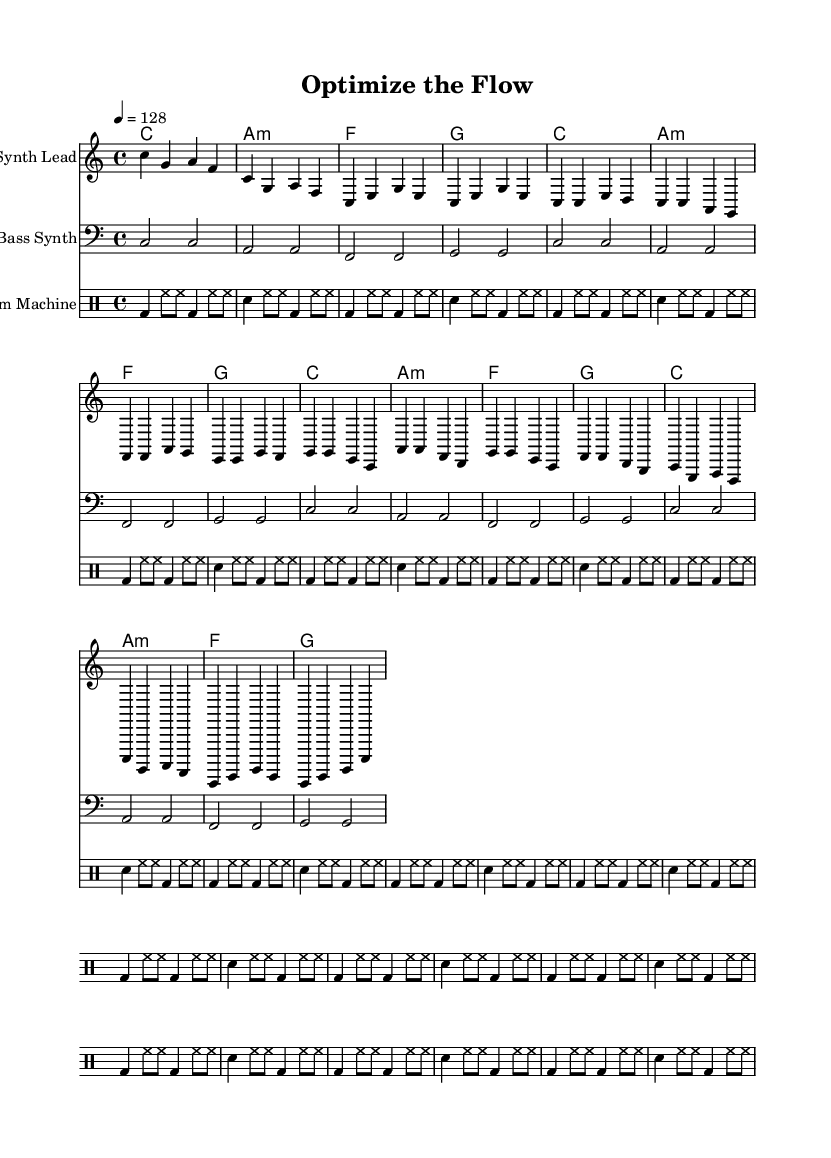What is the key signature of this music? The key signature is indicated at the beginning of the sheet music and shows C major, which has no sharps or flats.
Answer: C major What is the time signature of this music? The time signature is found at the beginning of the sheet music, showing 4/4, which means there are four beats in a measure and a quarter note gets one beat.
Answer: 4/4 What is the tempo marking for this piece? The tempo is specified as 4 = 128 at the start of the piece, indicating the speed of the music, which means to play at 128 beats per minute.
Answer: 128 What instruments are featured in the score? The score includes a "Synth Lead" staff for melody, a "Bass Synth" staff, and a "Drum Machine" staff for percussive elements, indicating the instruments used in this composition.
Answer: Synth Lead, Bass Synth, Drum Machine How many measures does the chorus section contain? By counting the measures within the chorus section in the melody line, we see there are four measures represented in that part of the song.
Answer: 4 What is the primary theme discussed in the lyrics? The lyrics focus on optimization and efficiency, emphasizing concepts such as maximizing gain, minimizing strain, and the importance of data-driven decisions, which reflects the song's theme.
Answer: Optimization and efficiency What is the last note in the melody? By examining the final phrase of the melody, the last note played is a C in the last measure of the staff.
Answer: C 